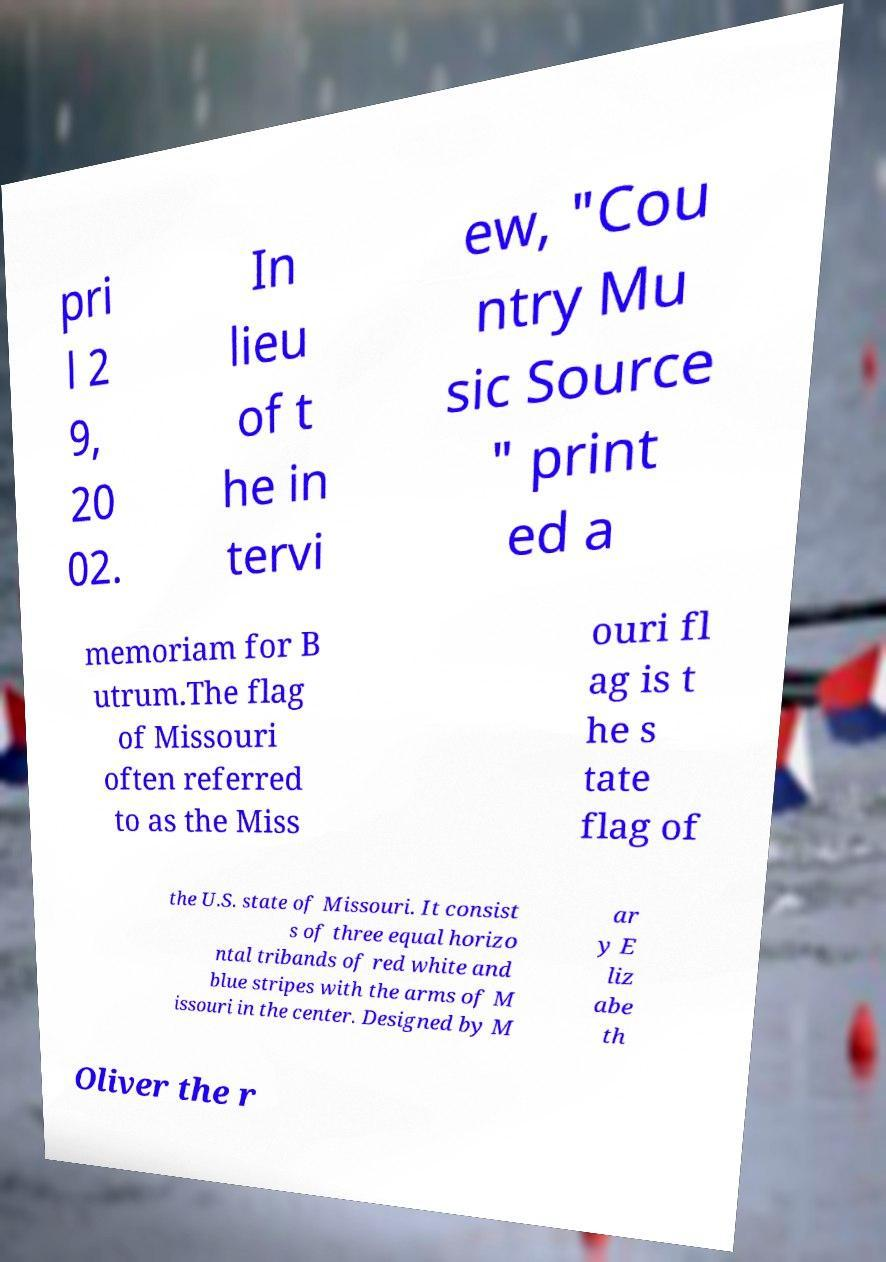I need the written content from this picture converted into text. Can you do that? pri l 2 9, 20 02. In lieu of t he in tervi ew, "Cou ntry Mu sic Source " print ed a memoriam for B utrum.The flag of Missouri often referred to as the Miss ouri fl ag is t he s tate flag of the U.S. state of Missouri. It consist s of three equal horizo ntal tribands of red white and blue stripes with the arms of M issouri in the center. Designed by M ar y E liz abe th Oliver the r 